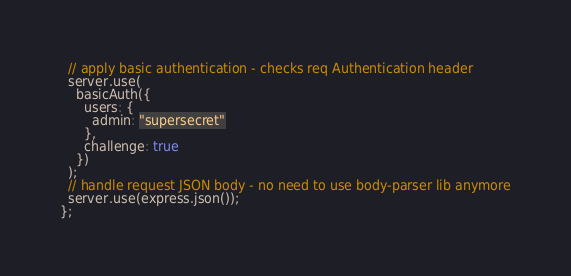Convert code to text. <code><loc_0><loc_0><loc_500><loc_500><_JavaScript_>  // apply basic authentication - checks req Authentication header
  server.use(
    basicAuth({
      users: {
        admin: "supersecret"
      },
      challenge: true
    })
  );
  // handle request JSON body - no need to use body-parser lib anymore
  server.use(express.json());
};
</code> 